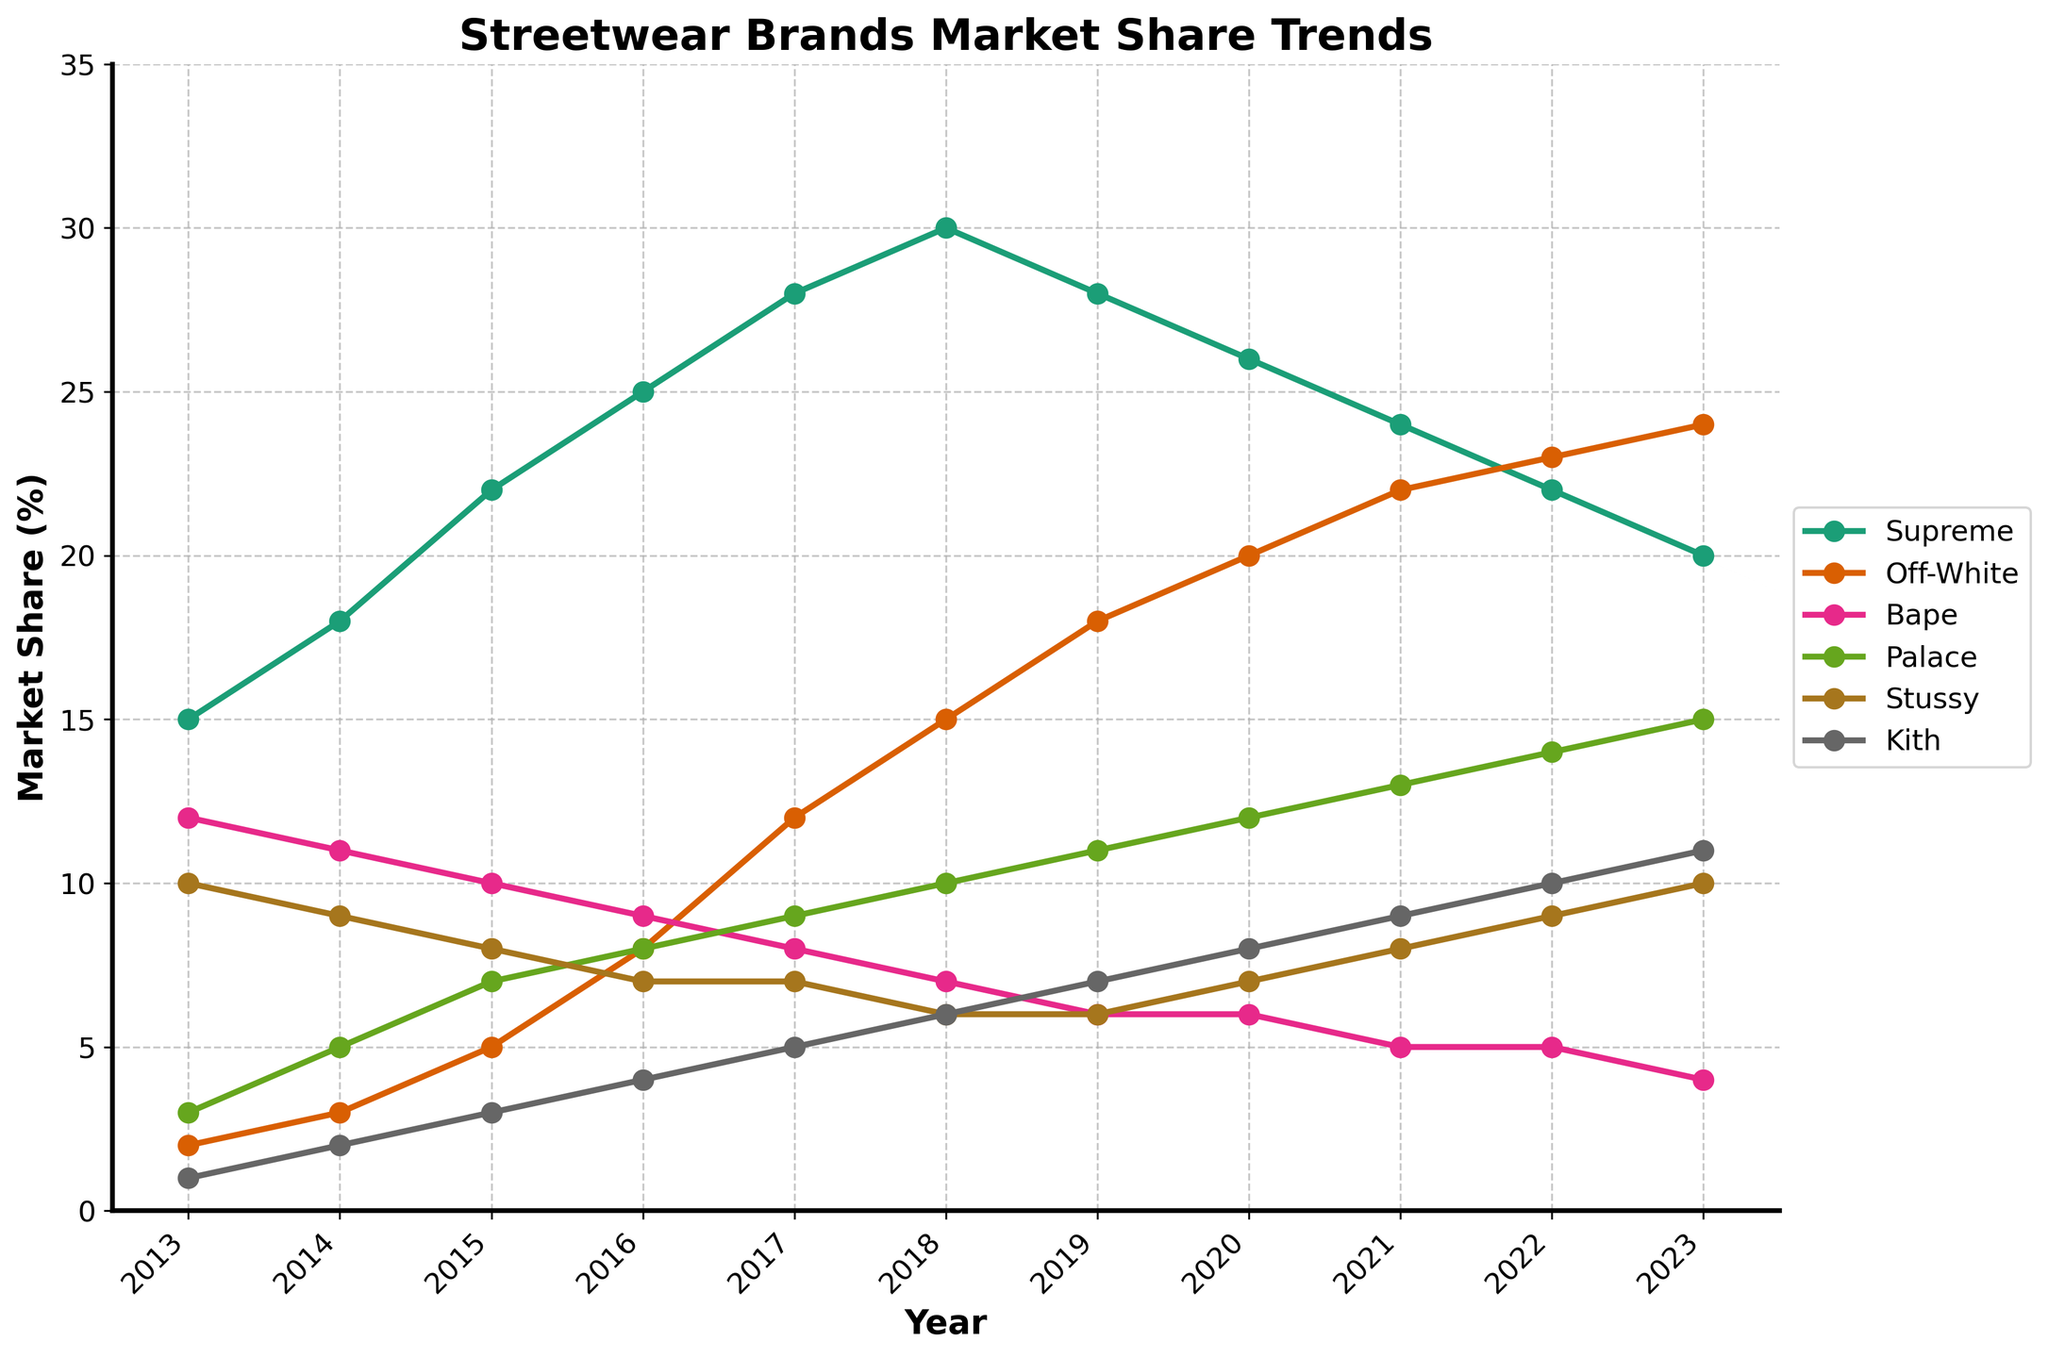Which brand had the highest market share in 2023? By observing the plotted lines, the brand with the highest percentage at the year 2023 is Off-White, reaching a market share around 24%.
Answer: Off-White Between 2015 and 2020, which brand showed the most consistent growth in market share? From the plotted lines, Kith consistently increased its market share each year from 2015 (3%) to 2020 (8%). Other brands either had periods of decline or lower growth consistency.
Answer: Kith Between Bape and Palace, which brand had a greater decrease in market share from 2013 to 2023? Bape had a drop from 12% in 2013 to 4% in 2023. Palace, on the other hand, increased from 3% in 2013 to 15% in 2023, meaning it did not decrease. Therefore, Bape showed a greater decrease.
Answer: Bape What is the sum of market shares of Supreme and Off-White in 2017? In 2017, Supreme had a market share of 28% and Off-White had 12%. The sum of these market shares is 28% + 12% = 40%.
Answer: 40% Which year did Stussy and Kith have the same market share? By inspecting the lines visually, Stussy and Kith both had a market share of 6% in the year 2018.
Answer: 2018 What is the average market share of Stussy from 2013 to 2023? Stussy's market shares over the years are [10, 9, 8, 7, 7, 6, 6, 7, 8, 9, 10]. The sum is 87. Dividing by the number of years (11), the average market share is 87/11 ≈ 7.91.
Answer: 7.91 Which brand experienced the biggest fall in market share in a single year, and in which year? Comparing the year-to-year changes, Supreme falls from 28% in 2018 to 26% in 2019, a drop of 2%. No other brand shows a larger single-year fall.
Answer: Supreme, 2019 Which two brands had their lines first intersect, and in which year? By examining the chart visually, Kith and Bape intersected in 2016 when both had around 4% market share.
Answer: Kith and Bape, 2016 